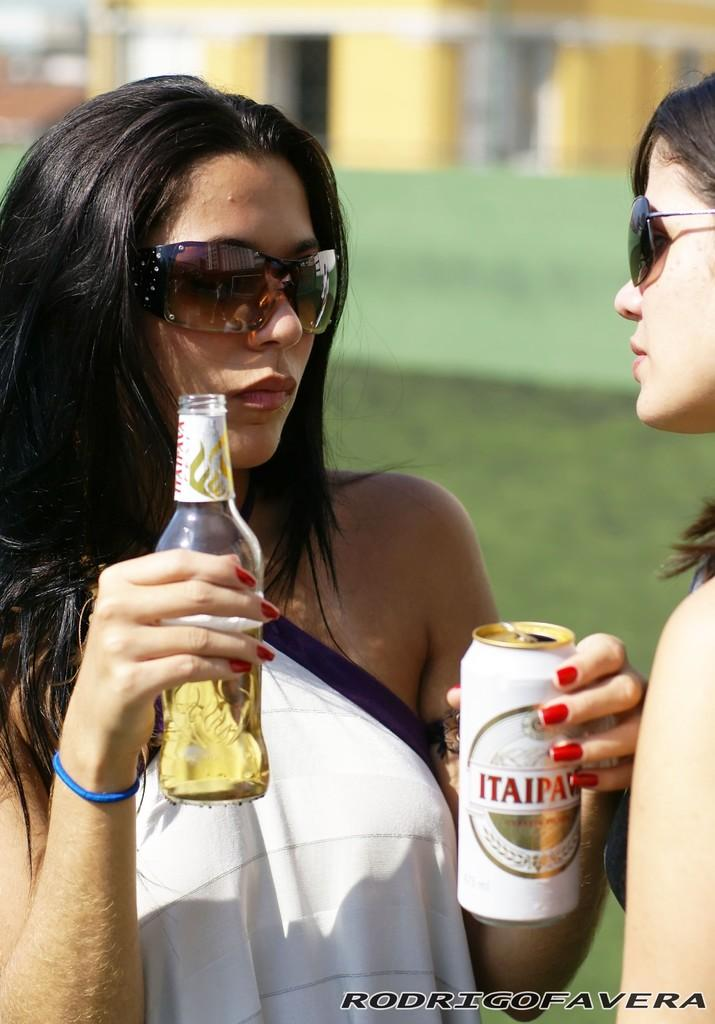How many people are in the image? There are two women in the image. What are the women holding in their hands? The women are holding a glass bottle in their hands. What type of beef is being served at the school in the image? There is no school or beef present in the image; it features two women holding a glass bottle. 